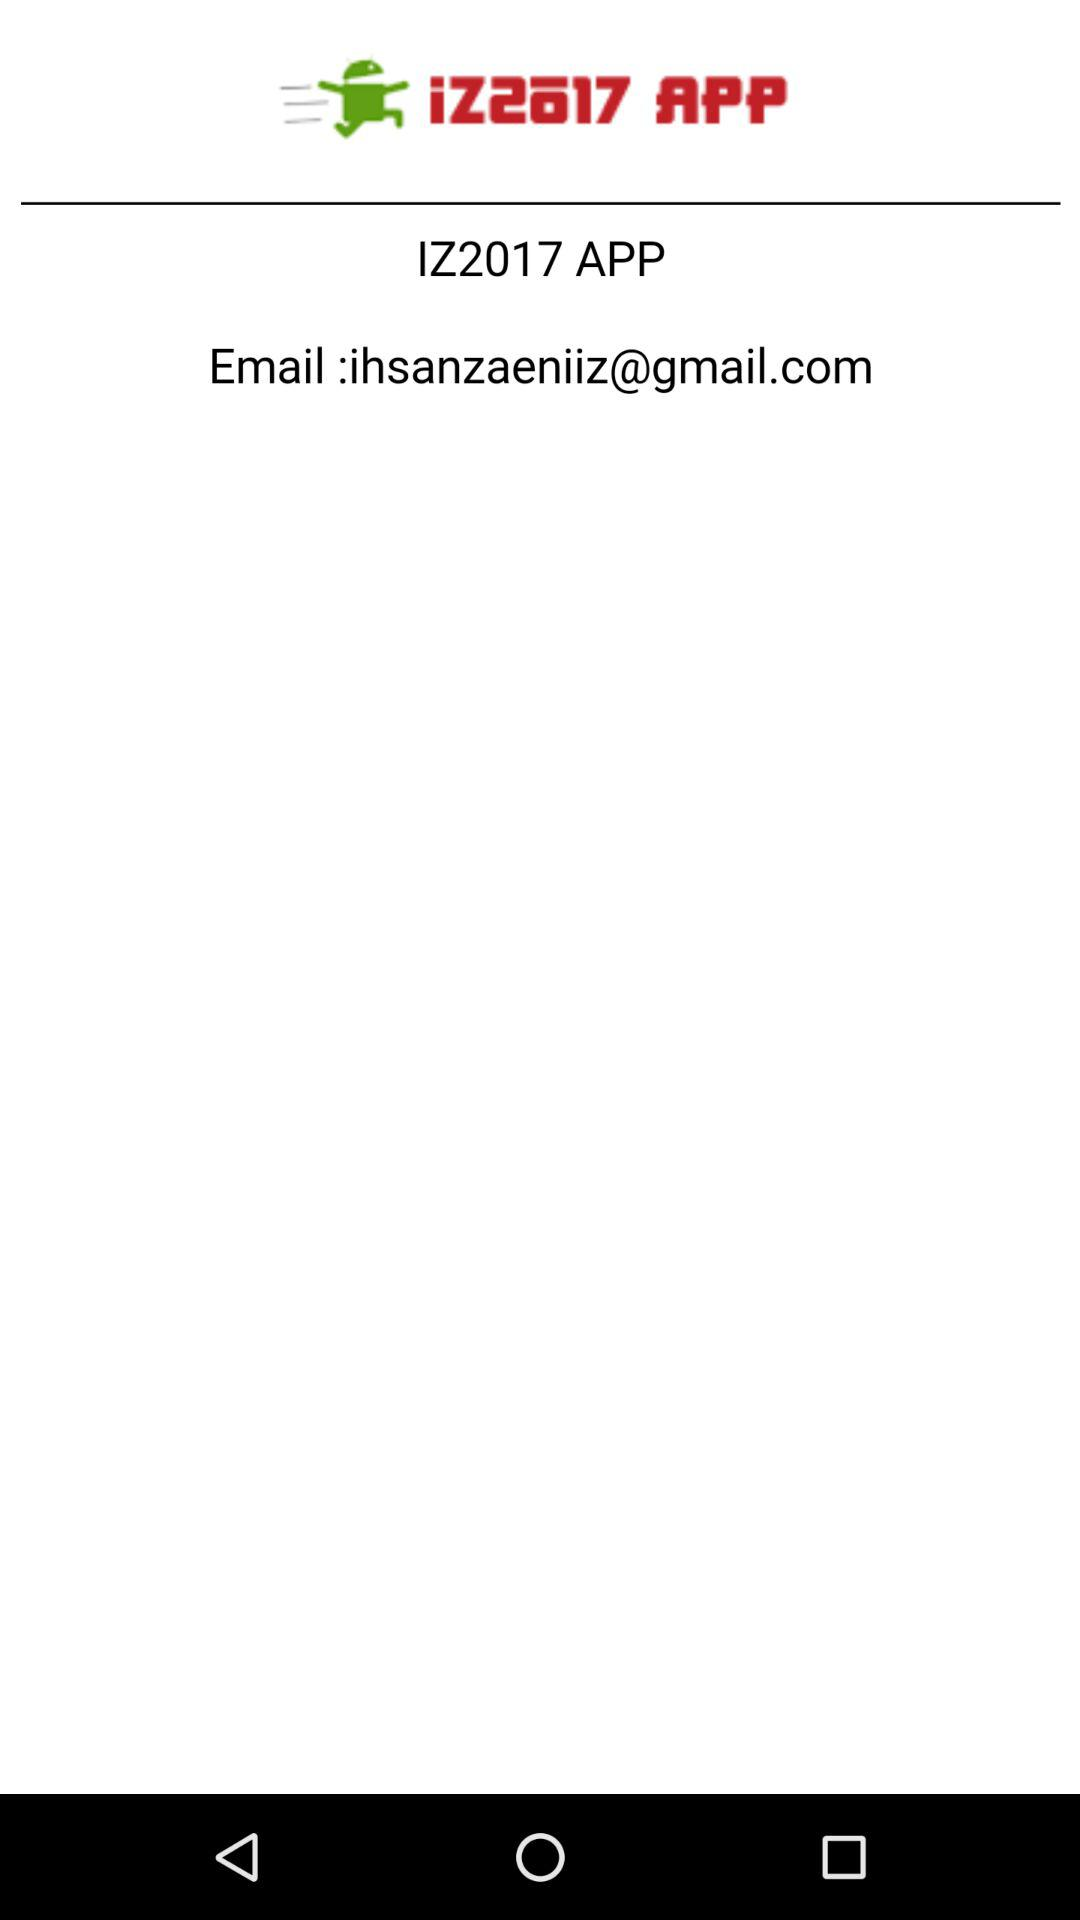What is the email address? The email address is ihsanzaeniiz@gmail.com. 